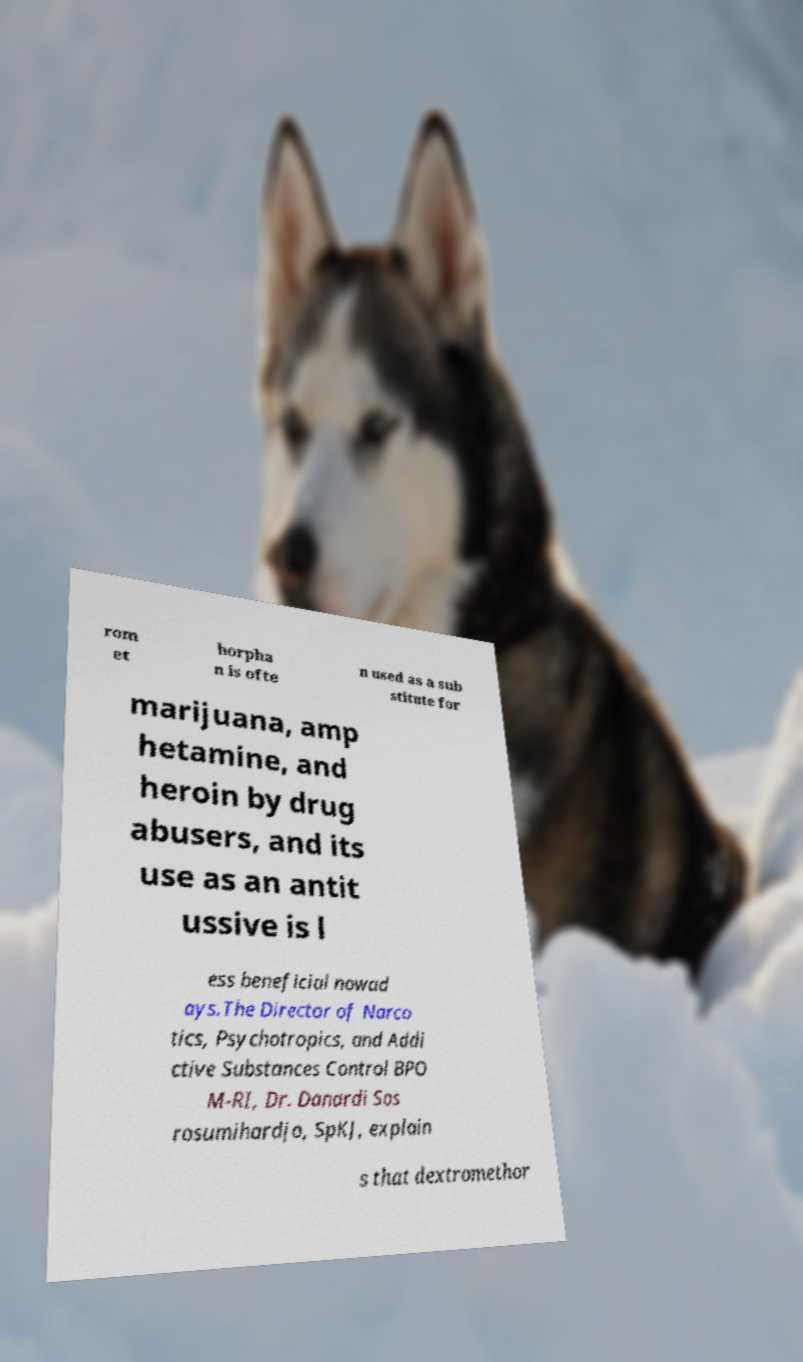Can you accurately transcribe the text from the provided image for me? rom et horpha n is ofte n used as a sub stitute for marijuana, amp hetamine, and heroin by drug abusers, and its use as an antit ussive is l ess beneficial nowad ays.The Director of Narco tics, Psychotropics, and Addi ctive Substances Control BPO M-RI, Dr. Danardi Sos rosumihardjo, SpKJ, explain s that dextromethor 